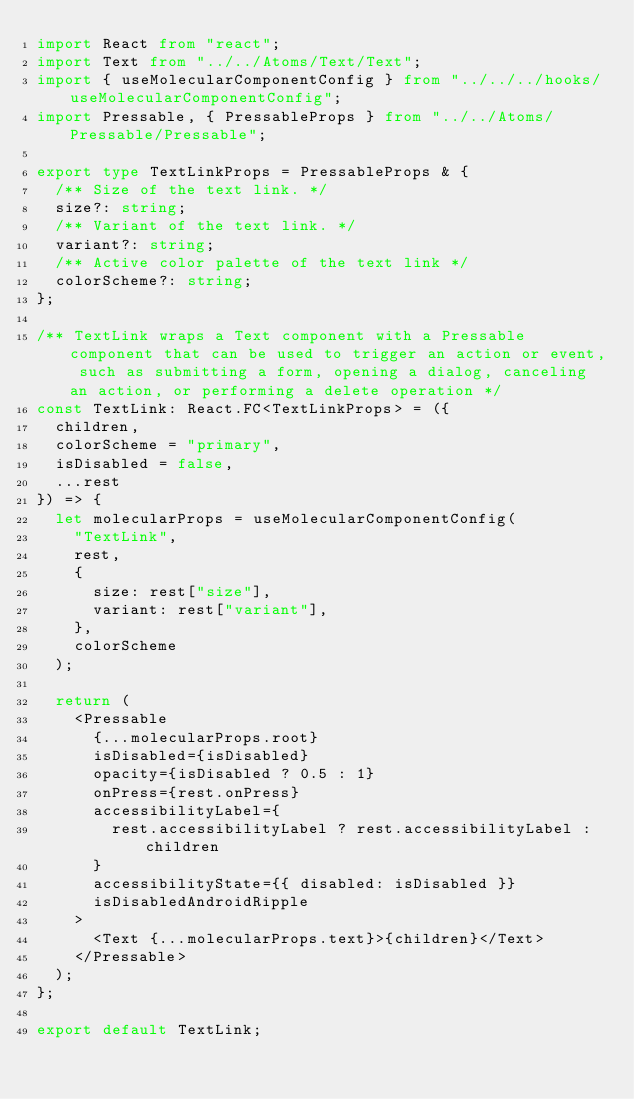Convert code to text. <code><loc_0><loc_0><loc_500><loc_500><_TypeScript_>import React from "react";
import Text from "../../Atoms/Text/Text";
import { useMolecularComponentConfig } from "../../../hooks/useMolecularComponentConfig";
import Pressable, { PressableProps } from "../../Atoms/Pressable/Pressable";

export type TextLinkProps = PressableProps & {
  /** Size of the text link. */
  size?: string;
  /** Variant of the text link. */
  variant?: string;
  /** Active color palette of the text link */
  colorScheme?: string;
};

/** TextLink wraps a Text component with a Pressable component that can be used to trigger an action or event, such as submitting a form, opening a dialog, canceling an action, or performing a delete operation */
const TextLink: React.FC<TextLinkProps> = ({
  children,
  colorScheme = "primary",
  isDisabled = false,
  ...rest
}) => {
  let molecularProps = useMolecularComponentConfig(
    "TextLink",
    rest,
    {
      size: rest["size"],
      variant: rest["variant"],
    },
    colorScheme
  );

  return (
    <Pressable
      {...molecularProps.root}
      isDisabled={isDisabled}
      opacity={isDisabled ? 0.5 : 1}
      onPress={rest.onPress}
      accessibilityLabel={
        rest.accessibilityLabel ? rest.accessibilityLabel : children
      }
      accessibilityState={{ disabled: isDisabled }}
      isDisabledAndroidRipple
    >
      <Text {...molecularProps.text}>{children}</Text>
    </Pressable>
  );
};

export default TextLink;
</code> 